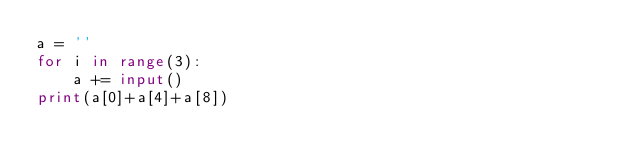<code> <loc_0><loc_0><loc_500><loc_500><_Python_>a = ''
for i in range(3):
    a += input()
print(a[0]+a[4]+a[8])</code> 